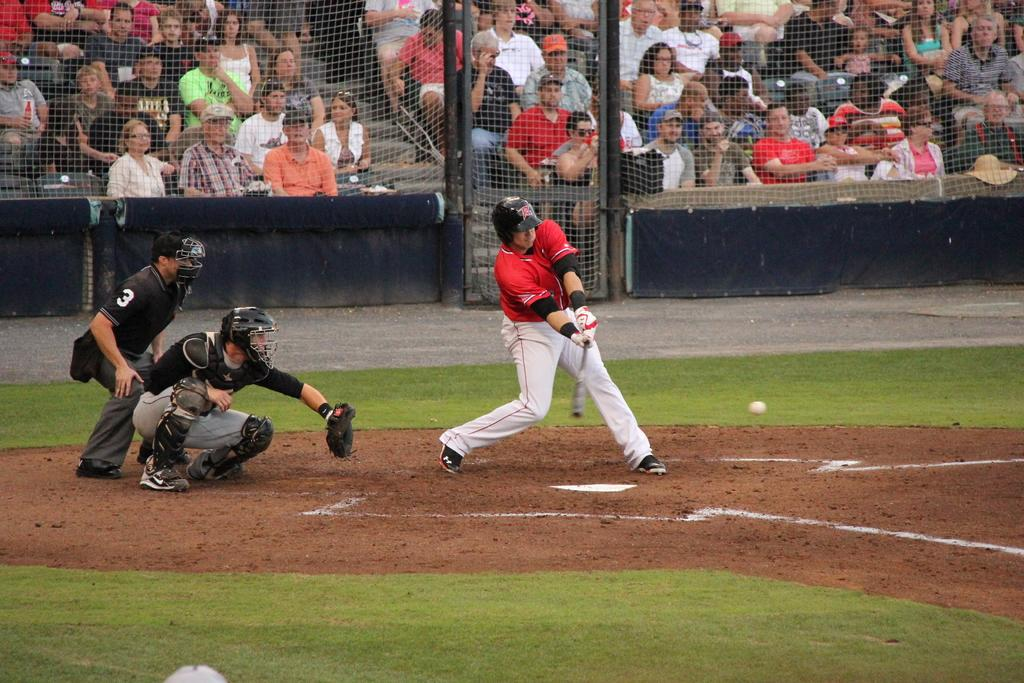Provide a one-sentence caption for the provided image. An umpire is on a baseball diamond with the number 3 on his sleeve. 